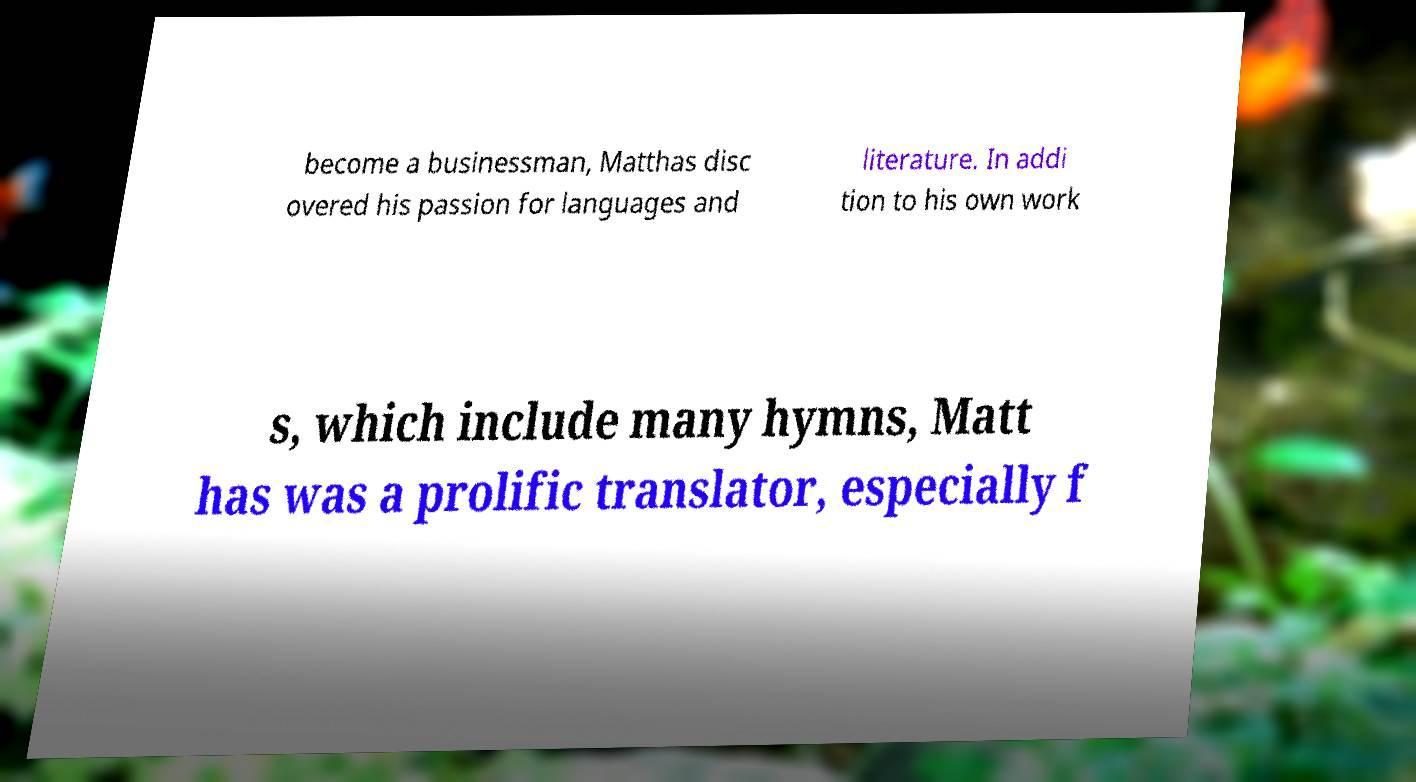There's text embedded in this image that I need extracted. Can you transcribe it verbatim? become a businessman, Matthas disc overed his passion for languages and literature. In addi tion to his own work s, which include many hymns, Matt has was a prolific translator, especially f 